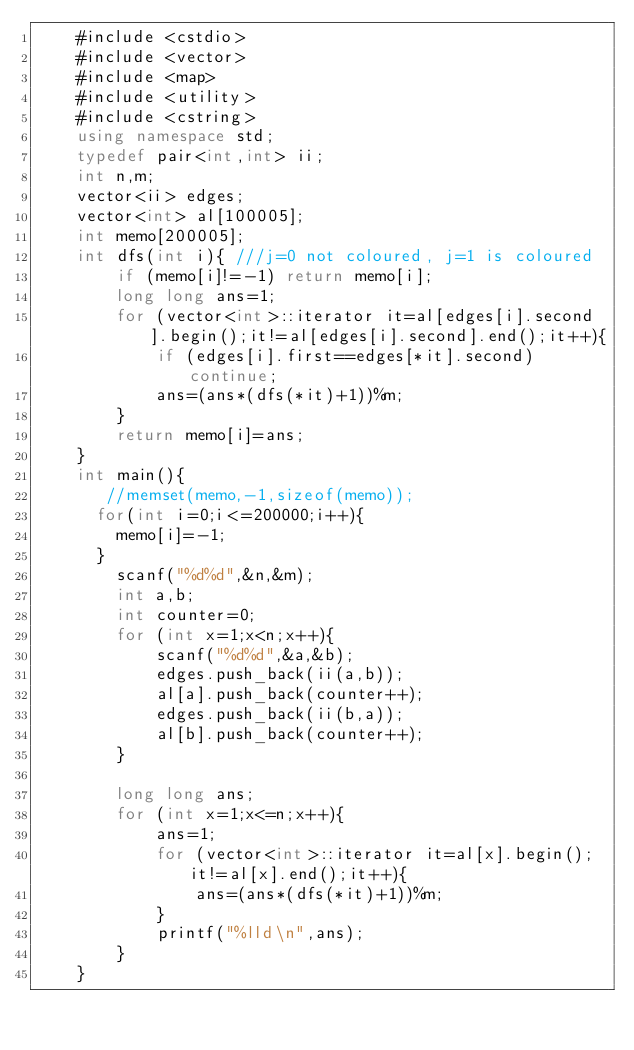Convert code to text. <code><loc_0><loc_0><loc_500><loc_500><_C++_>    #include <cstdio>
    #include <vector>
    #include <map>
    #include <utility>
    #include <cstring>
    using namespace std;
    typedef pair<int,int> ii;
    int n,m;
    vector<ii> edges;
    vector<int> al[100005];
    int memo[200005];
    int dfs(int i){ ///j=0 not coloured, j=1 is coloured
        if (memo[i]!=-1) return memo[i];
        long long ans=1;
        for (vector<int>::iterator it=al[edges[i].second].begin();it!=al[edges[i].second].end();it++){
            if (edges[i].first==edges[*it].second) continue;
            ans=(ans*(dfs(*it)+1))%m;
        }
        return memo[i]=ans;
    }
    int main(){
       //memset(memo,-1,sizeof(memo));
      for(int i=0;i<=200000;i++){
        memo[i]=-1;
      }
        scanf("%d%d",&n,&m);
        int a,b;
        int counter=0;
        for (int x=1;x<n;x++){
            scanf("%d%d",&a,&b);
            edges.push_back(ii(a,b));
            al[a].push_back(counter++);
            edges.push_back(ii(b,a));
            al[b].push_back(counter++);
        }
     
        long long ans;
        for (int x=1;x<=n;x++){
            ans=1;
            for (vector<int>::iterator it=al[x].begin();it!=al[x].end();it++){
                ans=(ans*(dfs(*it)+1))%m;
            }
            printf("%lld\n",ans);
        }
    }</code> 